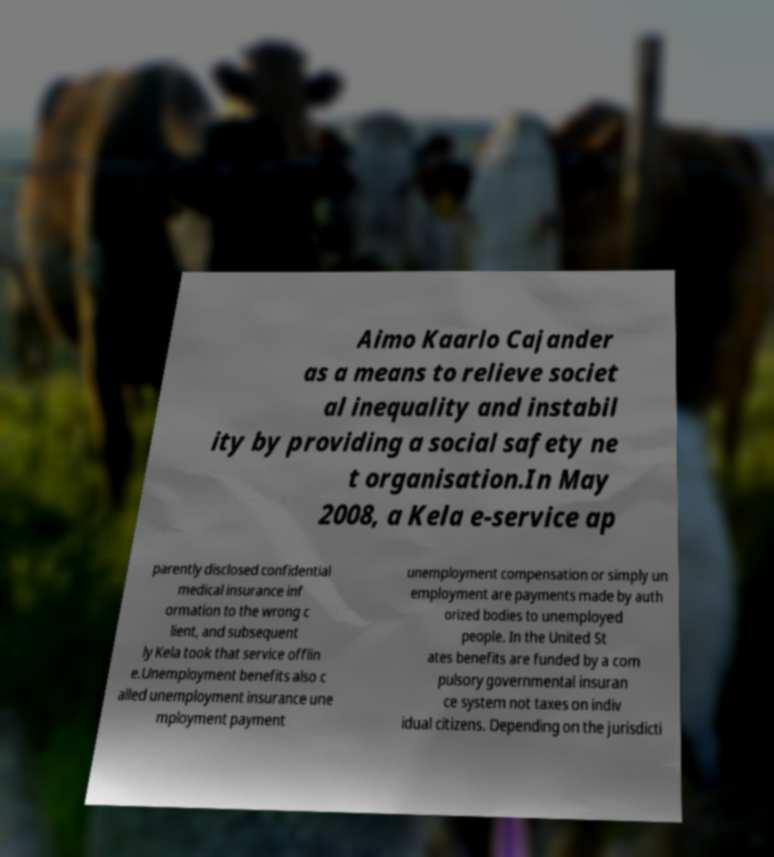Please identify and transcribe the text found in this image. Aimo Kaarlo Cajander as a means to relieve societ al inequality and instabil ity by providing a social safety ne t organisation.In May 2008, a Kela e-service ap parently disclosed confidential medical insurance inf ormation to the wrong c lient, and subsequent ly Kela took that service offlin e.Unemployment benefits also c alled unemployment insurance une mployment payment unemployment compensation or simply un employment are payments made by auth orized bodies to unemployed people. In the United St ates benefits are funded by a com pulsory governmental insuran ce system not taxes on indiv idual citizens. Depending on the jurisdicti 